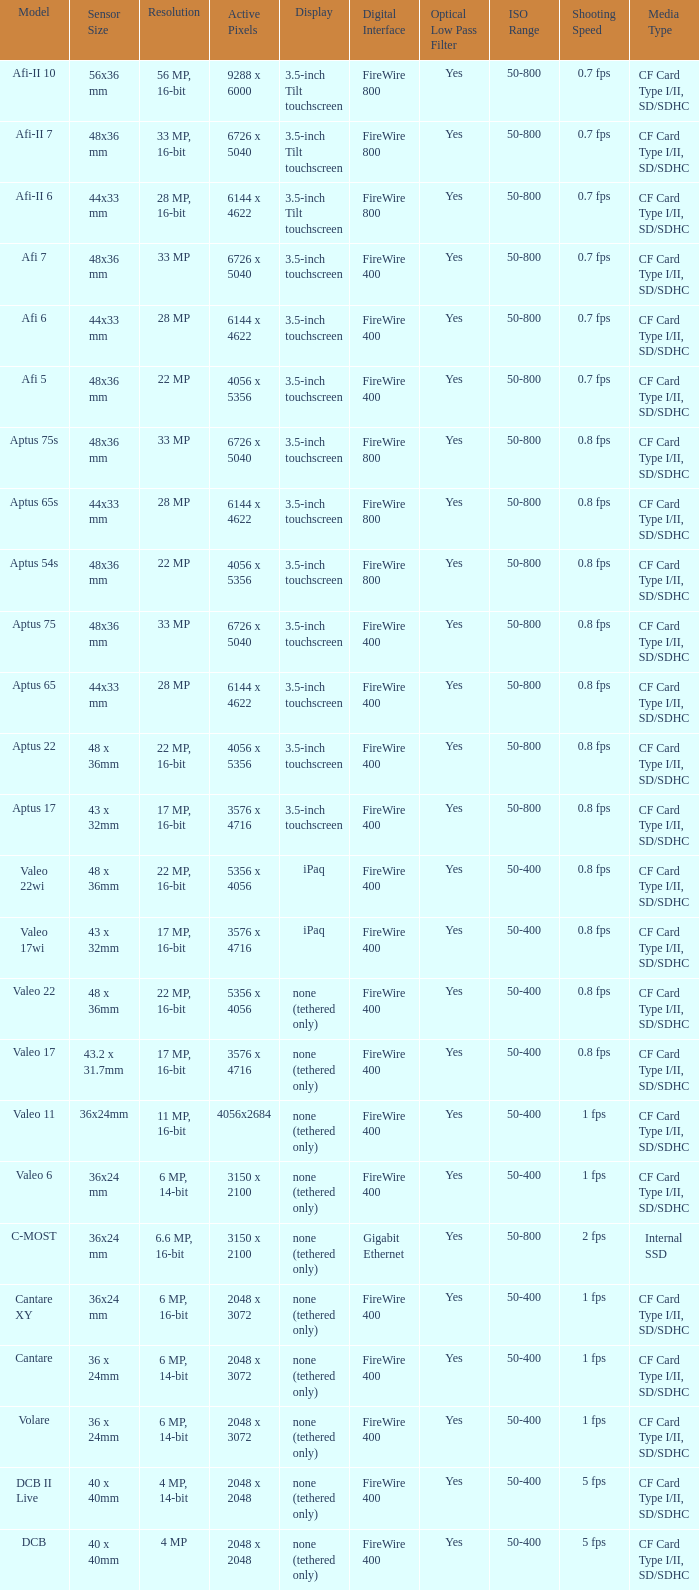Which model has a sensor sized 48x36 mm, pixels of 6726 x 5040, and a 33 mp resolution? Afi 7, Aptus 75s, Aptus 75. Would you be able to parse every entry in this table? {'header': ['Model', 'Sensor Size', 'Resolution', 'Active Pixels', 'Display', 'Digital Interface', 'Optical Low Pass Filter', 'ISO Range', 'Shooting Speed', 'Media Type'], 'rows': [['Afi-II 10', '56x36 mm', '56 MP, 16-bit', '9288 x 6000', '3.5-inch Tilt touchscreen', 'FireWire 800', 'Yes', '50-800', '0.7 fps', 'CF Card Type I/II, SD/SDHC'], ['Afi-II 7', '48x36 mm', '33 MP, 16-bit', '6726 x 5040', '3.5-inch Tilt touchscreen', 'FireWire 800', 'Yes', '50-800', '0.7 fps', 'CF Card Type I/II, SD/SDHC'], ['Afi-II 6', '44x33 mm', '28 MP, 16-bit', '6144 x 4622', '3.5-inch Tilt touchscreen', 'FireWire 800', 'Yes', '50-800', '0.7 fps', 'CF Card Type I/II, SD/SDHC'], ['Afi 7', '48x36 mm', '33 MP', '6726 x 5040', '3.5-inch touchscreen', 'FireWire 400', 'Yes', '50-800', '0.7 fps', 'CF Card Type I/II, SD/SDHC'], ['Afi 6', '44x33 mm', '28 MP', '6144 x 4622', '3.5-inch touchscreen', 'FireWire 400', 'Yes', '50-800', '0.7 fps', 'CF Card Type I/II, SD/SDHC'], ['Afi 5', '48x36 mm', '22 MP', '4056 x 5356', '3.5-inch touchscreen', 'FireWire 400', 'Yes', '50-800', '0.7 fps', 'CF Card Type I/II, SD/SDHC'], ['Aptus 75s', '48x36 mm', '33 MP', '6726 x 5040', '3.5-inch touchscreen', 'FireWire 800', 'Yes', '50-800', '0.8 fps', 'CF Card Type I/II, SD/SDHC'], ['Aptus 65s', '44x33 mm', '28 MP', '6144 x 4622', '3.5-inch touchscreen', 'FireWire 800', 'Yes', '50-800', '0.8 fps', 'CF Card Type I/II, SD/SDHC'], ['Aptus 54s', '48x36 mm', '22 MP', '4056 x 5356', '3.5-inch touchscreen', 'FireWire 800', 'Yes', '50-800', '0.8 fps', 'CF Card Type I/II, SD/SDHC'], ['Aptus 75', '48x36 mm', '33 MP', '6726 x 5040', '3.5-inch touchscreen', 'FireWire 400', 'Yes', '50-800', '0.8 fps', 'CF Card Type I/II, SD/SDHC'], ['Aptus 65', '44x33 mm', '28 MP', '6144 x 4622', '3.5-inch touchscreen', 'FireWire 400', 'Yes', '50-800', '0.8 fps', 'CF Card Type I/II, SD/SDHC'], ['Aptus 22', '48 x 36mm', '22 MP, 16-bit', '4056 x 5356', '3.5-inch touchscreen', 'FireWire 400', 'Yes', '50-800', '0.8 fps', 'CF Card Type I/II, SD/SDHC'], ['Aptus 17', '43 x 32mm', '17 MP, 16-bit', '3576 x 4716', '3.5-inch touchscreen', 'FireWire 400', 'Yes', '50-800', '0.8 fps', 'CF Card Type I/II, SD/SDHC'], ['Valeo 22wi', '48 x 36mm', '22 MP, 16-bit', '5356 x 4056', 'iPaq', 'FireWire 400', 'Yes', '50-400', '0.8 fps', 'CF Card Type I/II, SD/SDHC'], ['Valeo 17wi', '43 x 32mm', '17 MP, 16-bit', '3576 x 4716', 'iPaq', 'FireWire 400', 'Yes', '50-400', '0.8 fps', 'CF Card Type I/II, SD/SDHC'], ['Valeo 22', '48 x 36mm', '22 MP, 16-bit', '5356 x 4056', 'none (tethered only)', 'FireWire 400', 'Yes', '50-400', '0.8 fps', 'CF Card Type I/II, SD/SDHC'], ['Valeo 17', '43.2 x 31.7mm', '17 MP, 16-bit', '3576 x 4716', 'none (tethered only)', 'FireWire 400', 'Yes', '50-400', '0.8 fps', 'CF Card Type I/II, SD/SDHC'], ['Valeo 11', '36x24mm', '11 MP, 16-bit', '4056x2684', 'none (tethered only)', 'FireWire 400', 'Yes', '50-400', '1 fps', 'CF Card Type I/II, SD/SDHC'], ['Valeo 6', '36x24 mm', '6 MP, 14-bit', '3150 x 2100', 'none (tethered only)', 'FireWire 400', 'Yes', '50-400', '1 fps', 'CF Card Type I/II, SD/SDHC'], ['C-MOST', '36x24 mm', '6.6 MP, 16-bit', '3150 x 2100', 'none (tethered only)', 'Gigabit Ethernet', 'Yes', '50-800', '2 fps', 'Internal SSD'], ['Cantare XY', '36x24 mm', '6 MP, 16-bit', '2048 x 3072', 'none (tethered only)', 'FireWire 400', 'Yes', '50-400', '1 fps', 'CF Card Type I/II, SD/SDHC'], ['Cantare', '36 x 24mm', '6 MP, 14-bit', '2048 x 3072', 'none (tethered only)', 'FireWire 400', 'Yes', '50-400', '1 fps', 'CF Card Type I/II, SD/SDHC'], ['Volare', '36 x 24mm', '6 MP, 14-bit', '2048 x 3072', 'none (tethered only)', 'FireWire 400', 'Yes', '50-400', '1 fps', 'CF Card Type I/II, SD/SDHC'], ['DCB II Live', '40 x 40mm', '4 MP, 14-bit', '2048 x 2048', 'none (tethered only)', 'FireWire 400', 'Yes', '50-400', '5 fps', 'CF Card Type I/II, SD/SDHC'], ['DCB', '40 x 40mm', '4 MP', '2048 x 2048', 'none (tethered only)', 'FireWire 400', 'Yes', '50-400', '5 fps', 'CF Card Type I/II, SD/SDHC']]} 